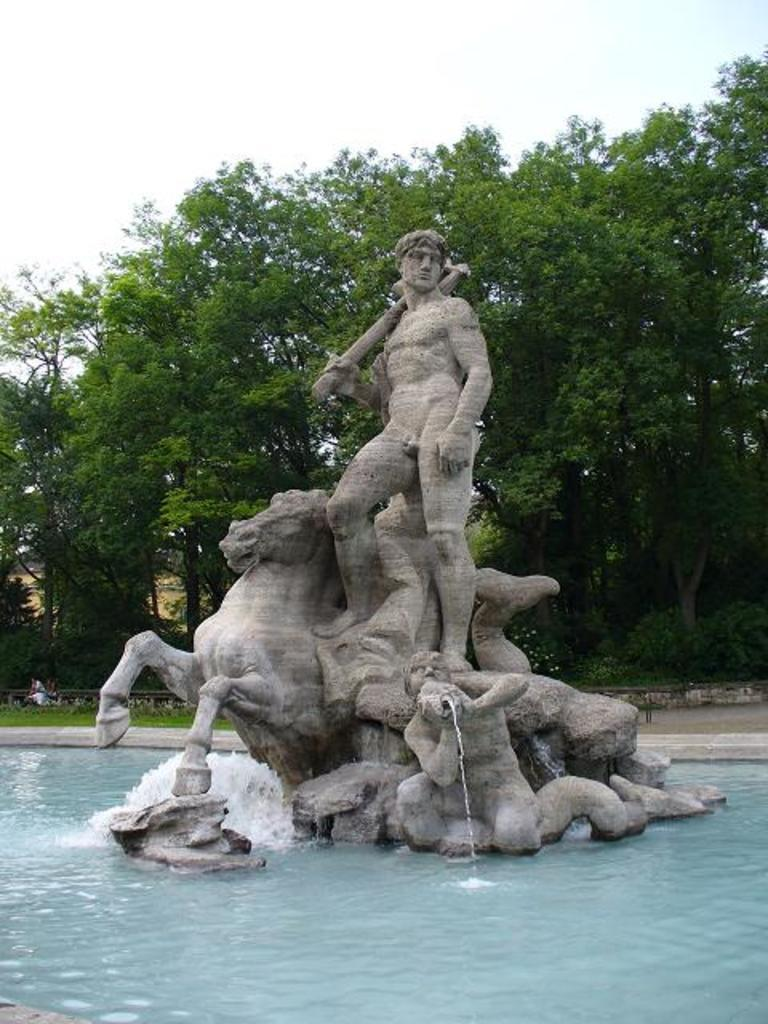What is the main feature in the image? There is a fountain in the image. What can be seen in the middle of the fountain? There are sculptures in the middle of the fountain. What type of vegetation is visible in the background of the image? There are trees in the background of the image. What is visible in the sky in the background of the image? The sky is visible in the background of the image. What type of canvas is used to create the sculptures in the image? The sculptures in the image are not made of canvas; they are sculpted from a solid material, such as stone or metal. 